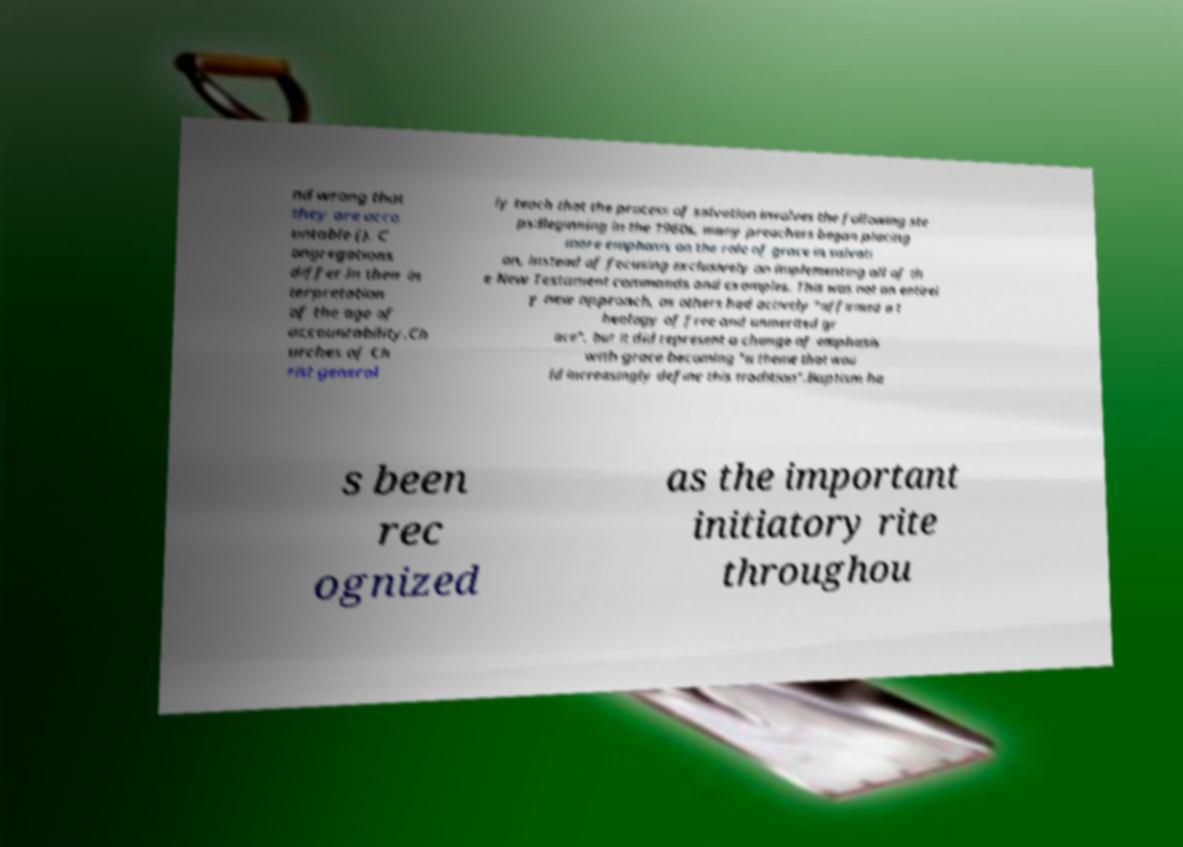There's text embedded in this image that I need extracted. Can you transcribe it verbatim? nd wrong that they are acco untable (). C ongregations differ in their in terpretation of the age of accountability.Ch urches of Ch rist general ly teach that the process of salvation involves the following ste ps:Beginning in the 1960s, many preachers began placing more emphasis on the role of grace in salvati on, instead of focusing exclusively on implementing all of th e New Testament commands and examples. This was not an entirel y new approach, as others had actively "affirmed a t heology of free and unmerited gr ace", but it did represent a change of emphasis with grace becoming "a theme that wou ld increasingly define this tradition".Baptism ha s been rec ognized as the important initiatory rite throughou 